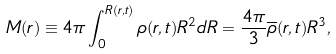<formula> <loc_0><loc_0><loc_500><loc_500>M ( r ) \equiv 4 \pi \int ^ { R ( r , t ) } _ { 0 } \rho ( r , t ) R ^ { 2 } d R = \frac { 4 \pi } { 3 } \overline { \rho } ( r , t ) R ^ { 3 } ,</formula> 